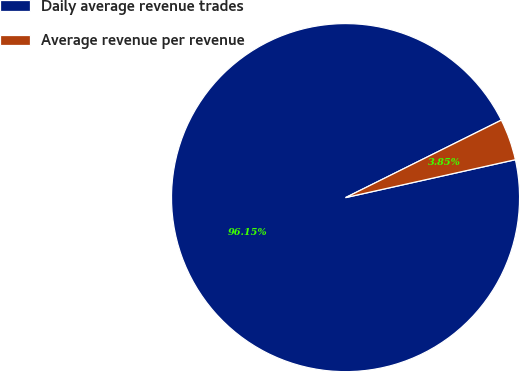<chart> <loc_0><loc_0><loc_500><loc_500><pie_chart><fcel>Daily average revenue trades<fcel>Average revenue per revenue<nl><fcel>96.15%<fcel>3.85%<nl></chart> 